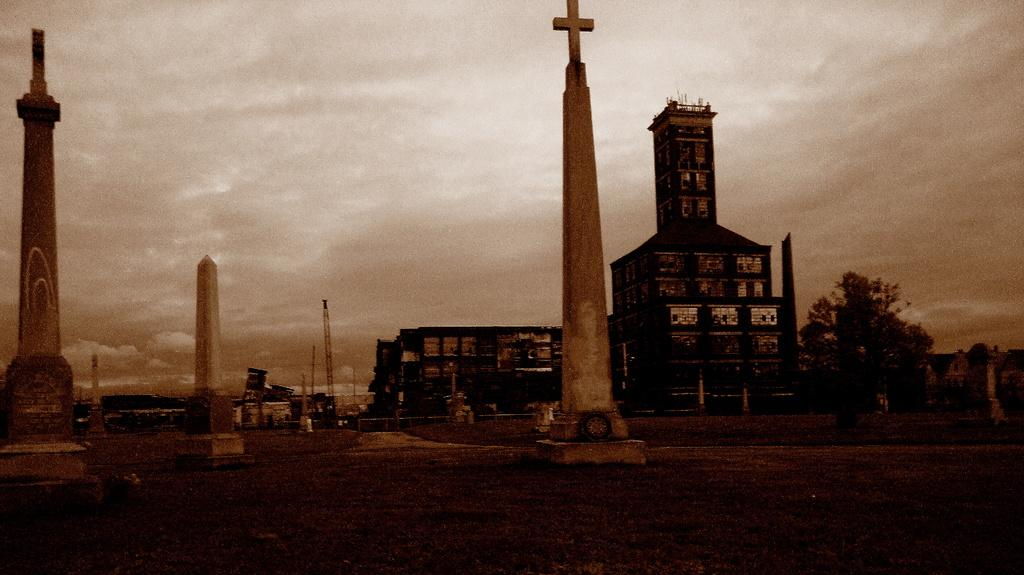What type of structures can be seen in the image? There are buildings and towers in the image. What is located at the bottom of the image? There is a road at the bottom of the image. What type of vegetation is visible in the image? Trees are visible in the image. What else can be seen in the image besides buildings and trees? Poles are present in the image. What is visible in the background of the image? The sky is visible in the image. Where are the cherries hanging in the image? There are no cherries present in the image. What is the wish that the church in the image is granting? There is no church present in the image, so it cannot grant any wishes. 